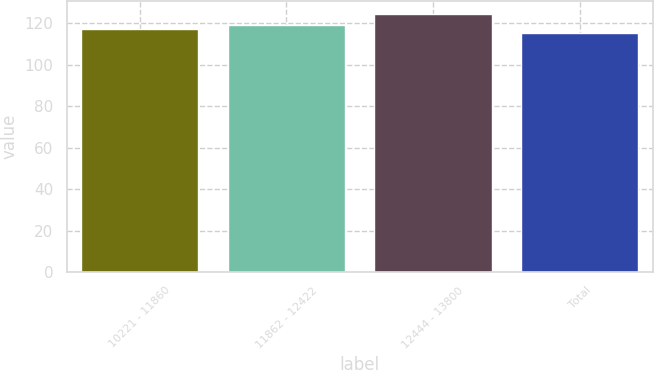<chart> <loc_0><loc_0><loc_500><loc_500><bar_chart><fcel>10221 - 11860<fcel>11862 - 12422<fcel>12444 - 13800<fcel>Total<nl><fcel>117.14<fcel>119.19<fcel>124.65<fcel>115.39<nl></chart> 